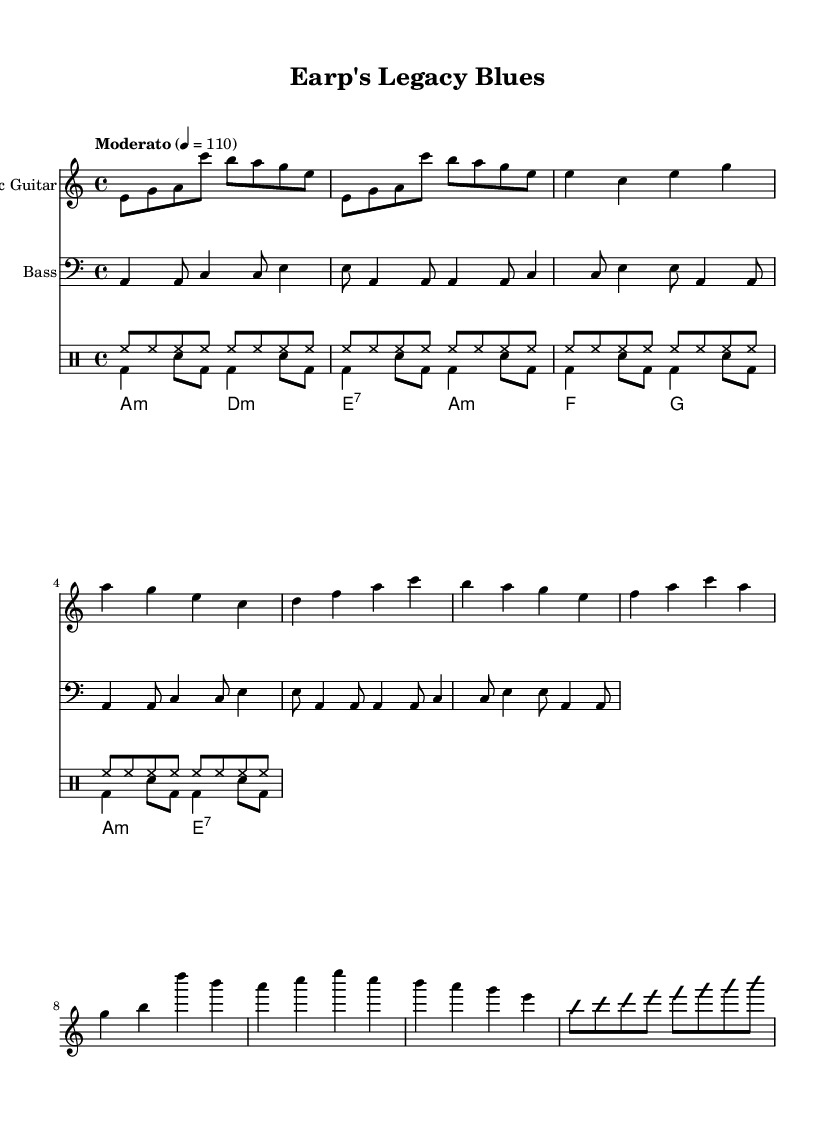What is the key signature of this music? The key signature is A minor, which has no sharps or flats. It can be identified by the 'a' in the key signature section of the sheet music.
Answer: A minor What is the time signature of this music? The time signature is 4/4, which indicates there are four beats in each measure and the quarter note gets one beat. It is presented at the beginning of the score, indicating the overall structure of the piece.
Answer: 4/4 What is the tempo marking for this music? The tempo marking is "Moderato" and indicates a moderate speed, which is denoted by '4 = 110' indicating a metronomic speed of 110 beats per minute.
Answer: Moderato What instruments are included in the score? The instruments included in the score are Electric Guitar, Bass, and Drums. Each instrument is clearly labeled at the beginning of its respective staff in the sheet music.
Answer: Electric Guitar, Bass, Drums How many measures are in the guitar solo section? The guitar solo section contains four measures, as indicated by the pattern of notes and rests that unfold within that part of the score.
Answer: Four What style is depicted in this music based on its elements? The music showcases an Electric Blues style with elements such as improvisation in the guitar part and blues-style chord progressions, which is characteristic of the genre.
Answer: Electric Blues How many times is the intro repeated? The intro is repeated 2 times, which is indicated by the 'repeat unfold 2' notation at the start of the guitar part.
Answer: Two times 